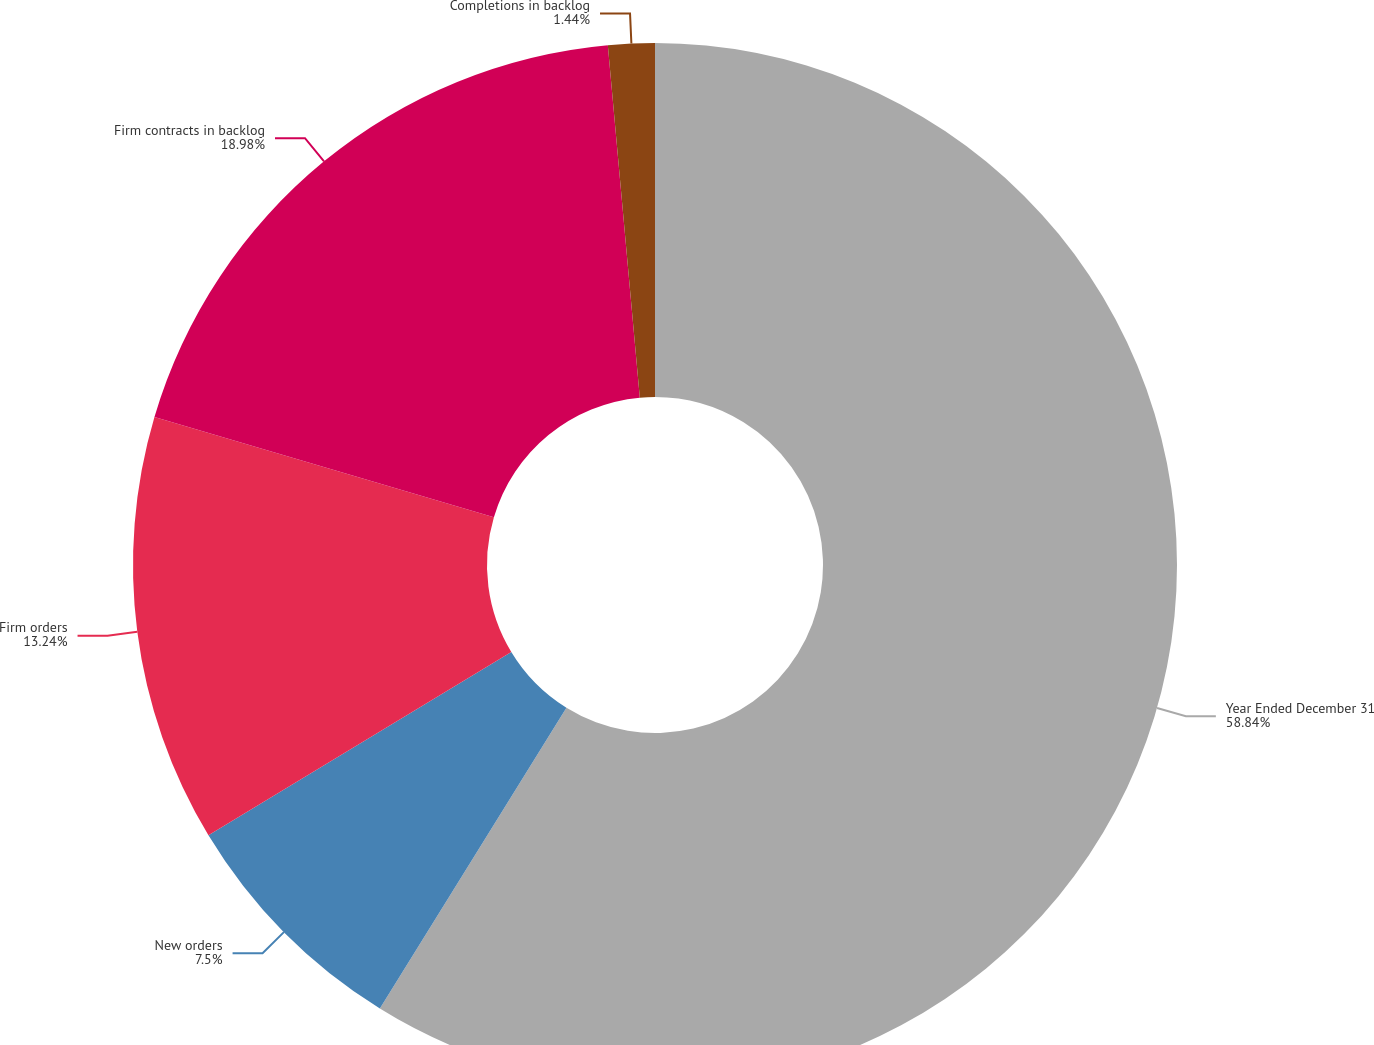<chart> <loc_0><loc_0><loc_500><loc_500><pie_chart><fcel>Year Ended December 31<fcel>New orders<fcel>Firm orders<fcel>Firm contracts in backlog<fcel>Completions in backlog<nl><fcel>58.83%<fcel>7.5%<fcel>13.24%<fcel>18.98%<fcel>1.44%<nl></chart> 